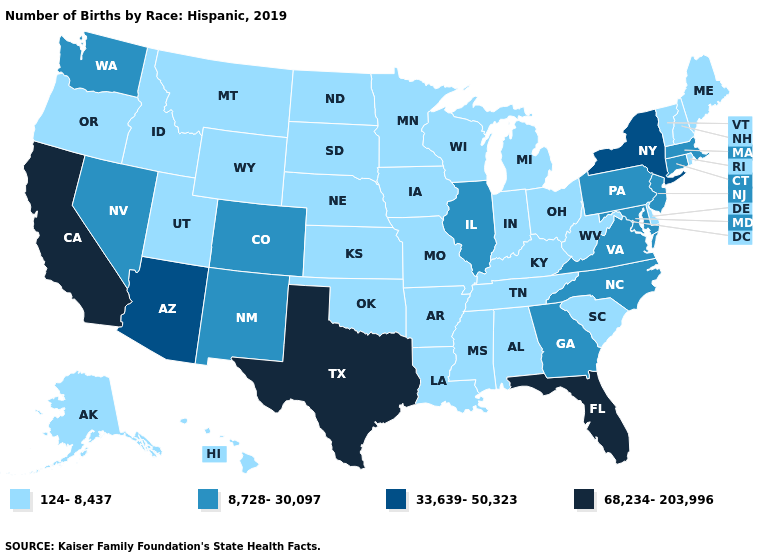Which states have the lowest value in the USA?
Keep it brief. Alabama, Alaska, Arkansas, Delaware, Hawaii, Idaho, Indiana, Iowa, Kansas, Kentucky, Louisiana, Maine, Michigan, Minnesota, Mississippi, Missouri, Montana, Nebraska, New Hampshire, North Dakota, Ohio, Oklahoma, Oregon, Rhode Island, South Carolina, South Dakota, Tennessee, Utah, Vermont, West Virginia, Wisconsin, Wyoming. What is the value of Pennsylvania?
Concise answer only. 8,728-30,097. Name the states that have a value in the range 124-8,437?
Concise answer only. Alabama, Alaska, Arkansas, Delaware, Hawaii, Idaho, Indiana, Iowa, Kansas, Kentucky, Louisiana, Maine, Michigan, Minnesota, Mississippi, Missouri, Montana, Nebraska, New Hampshire, North Dakota, Ohio, Oklahoma, Oregon, Rhode Island, South Carolina, South Dakota, Tennessee, Utah, Vermont, West Virginia, Wisconsin, Wyoming. What is the value of Ohio?
Answer briefly. 124-8,437. Does Georgia have a higher value than South Carolina?
Short answer required. Yes. Does New Mexico have the same value as Wisconsin?
Short answer required. No. Does Washington have the same value as Illinois?
Keep it brief. Yes. Is the legend a continuous bar?
Concise answer only. No. What is the highest value in the Northeast ?
Answer briefly. 33,639-50,323. Does Wisconsin have a lower value than Mississippi?
Concise answer only. No. How many symbols are there in the legend?
Give a very brief answer. 4. Does Oklahoma have the same value as Oregon?
Short answer required. Yes. What is the value of North Dakota?
Concise answer only. 124-8,437. Does Alabama have the lowest value in the South?
Write a very short answer. Yes. Name the states that have a value in the range 8,728-30,097?
Write a very short answer. Colorado, Connecticut, Georgia, Illinois, Maryland, Massachusetts, Nevada, New Jersey, New Mexico, North Carolina, Pennsylvania, Virginia, Washington. 